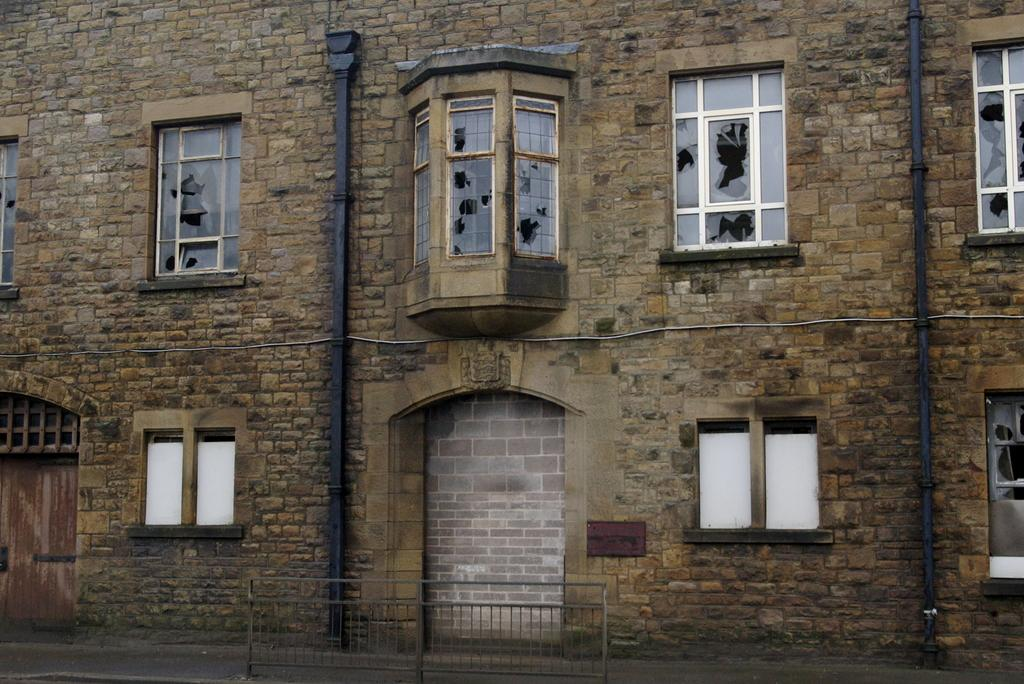What is the main subject of the image? The main subject of the image is a building. What specific features can be observed on the building? The building has windows, and there are holes in the windows. Is there any other significant object or structure within the building? Yes, there is a pipe in the middle of the building. What type of gold object can be seen in the image? There is no gold object present in the image. What emotion is the building expressing in the image? Buildings do not express emotions, so this question cannot be answered. 